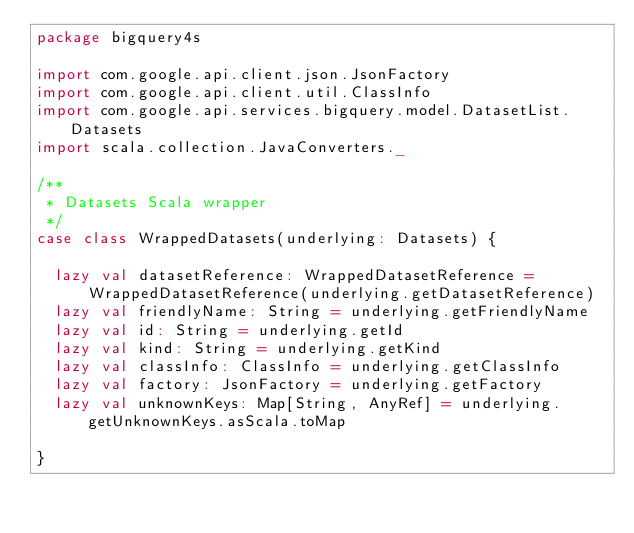Convert code to text. <code><loc_0><loc_0><loc_500><loc_500><_Scala_>package bigquery4s

import com.google.api.client.json.JsonFactory
import com.google.api.client.util.ClassInfo
import com.google.api.services.bigquery.model.DatasetList.Datasets
import scala.collection.JavaConverters._

/**
 * Datasets Scala wrapper
 */
case class WrappedDatasets(underlying: Datasets) {

  lazy val datasetReference: WrappedDatasetReference = WrappedDatasetReference(underlying.getDatasetReference)
  lazy val friendlyName: String = underlying.getFriendlyName
  lazy val id: String = underlying.getId
  lazy val kind: String = underlying.getKind
  lazy val classInfo: ClassInfo = underlying.getClassInfo
  lazy val factory: JsonFactory = underlying.getFactory
  lazy val unknownKeys: Map[String, AnyRef] = underlying.getUnknownKeys.asScala.toMap

}
</code> 